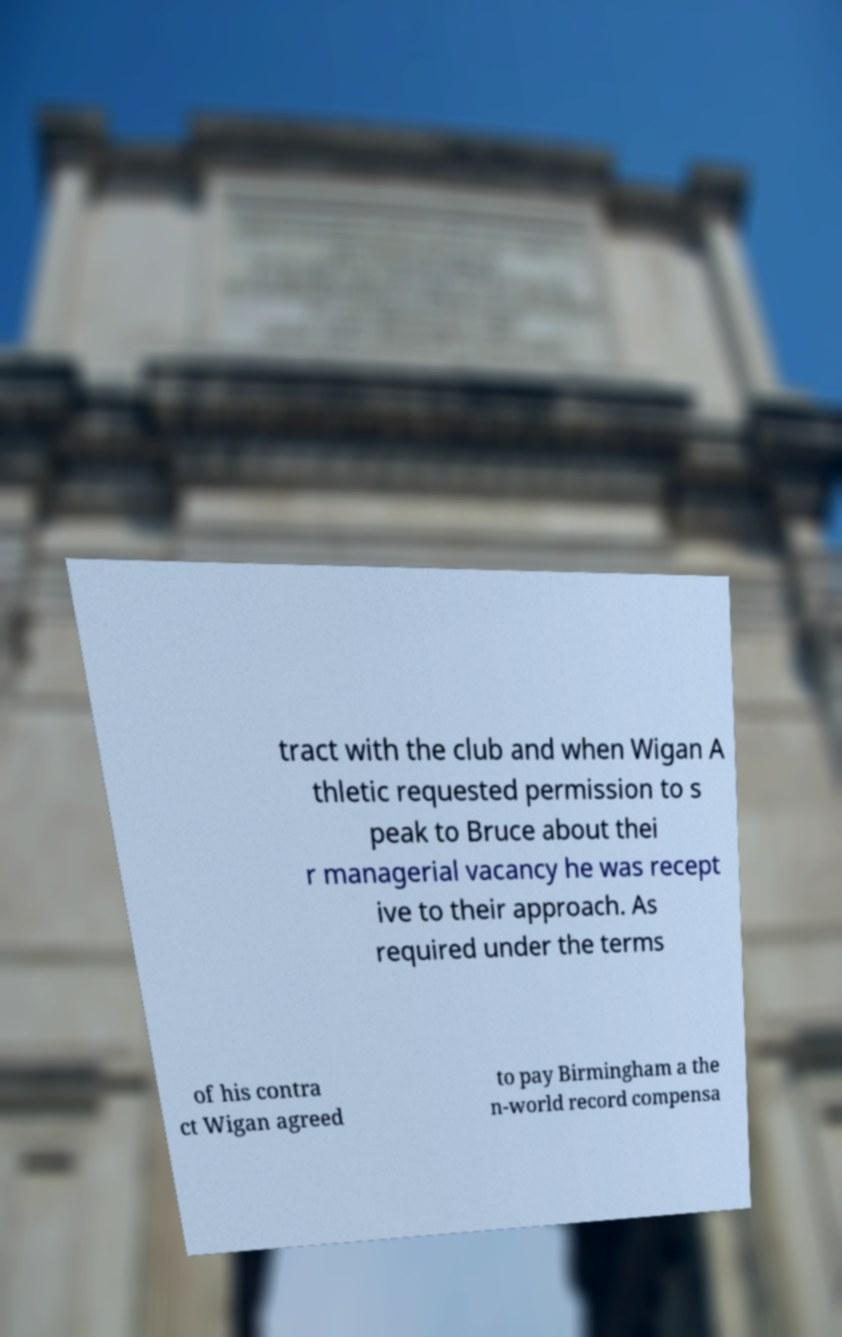Please read and relay the text visible in this image. What does it say? tract with the club and when Wigan A thletic requested permission to s peak to Bruce about thei r managerial vacancy he was recept ive to their approach. As required under the terms of his contra ct Wigan agreed to pay Birmingham a the n-world record compensa 